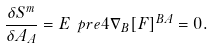<formula> <loc_0><loc_0><loc_500><loc_500>\frac { \delta S ^ { m } } { \delta A _ { A } } = E \ p r e { 4 } \nabla _ { B } [ F ] ^ { B A } = 0 .</formula> 